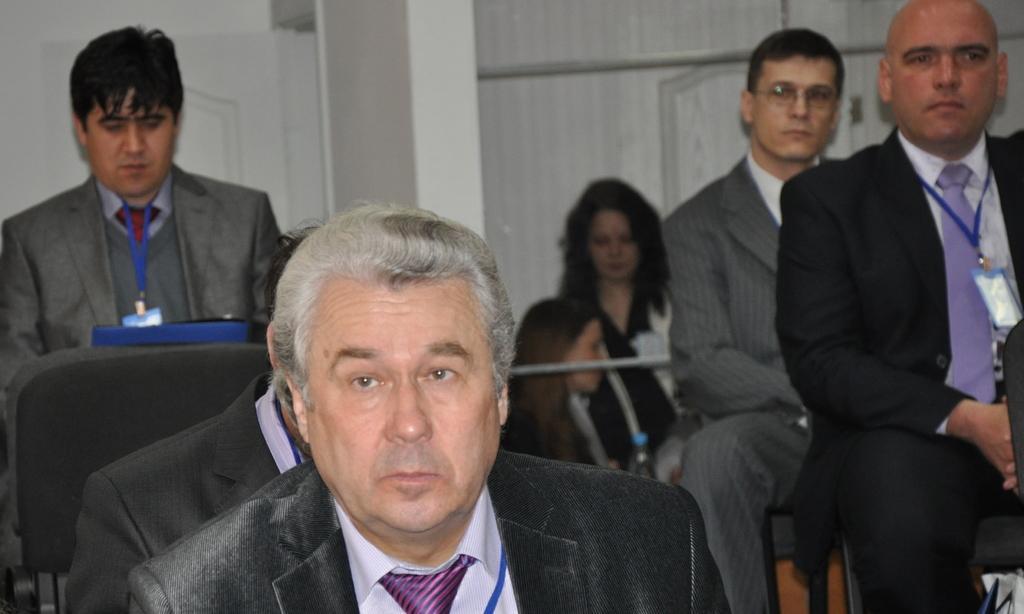Please provide a concise description of this image. In this picture we can see some people sitting here, in the background there is a wall, these persons wore suits. 